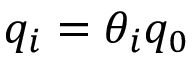Convert formula to latex. <formula><loc_0><loc_0><loc_500><loc_500>q _ { i } = \theta _ { i } q _ { 0 }</formula> 